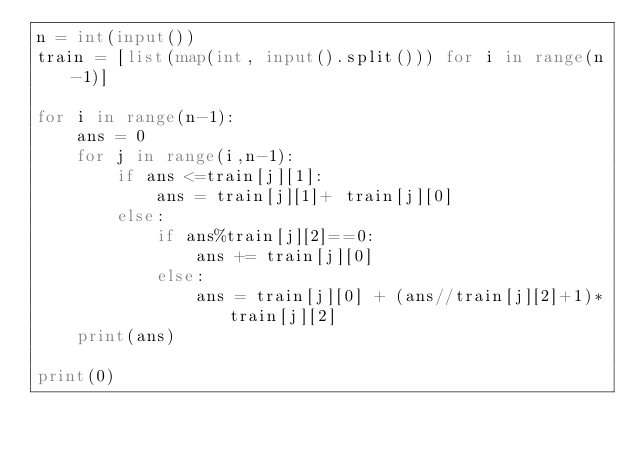<code> <loc_0><loc_0><loc_500><loc_500><_Python_>n = int(input())
train = [list(map(int, input().split())) for i in range(n-1)]

for i in range(n-1):
    ans = 0
    for j in range(i,n-1):
        if ans <=train[j][1]:
            ans = train[j][1]+ train[j][0]
        else:
            if ans%train[j][2]==0:
                ans += train[j][0]
            else:
                ans = train[j][0] + (ans//train[j][2]+1)*train[j][2]
    print(ans)

print(0)</code> 